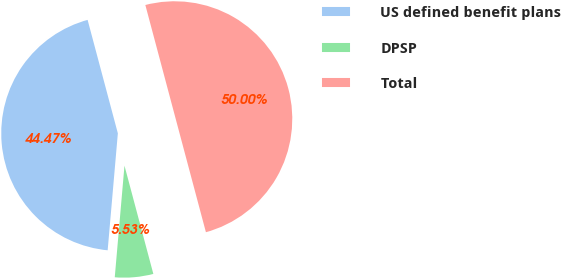Convert chart. <chart><loc_0><loc_0><loc_500><loc_500><pie_chart><fcel>US defined benefit plans<fcel>DPSP<fcel>Total<nl><fcel>44.47%<fcel>5.53%<fcel>50.0%<nl></chart> 